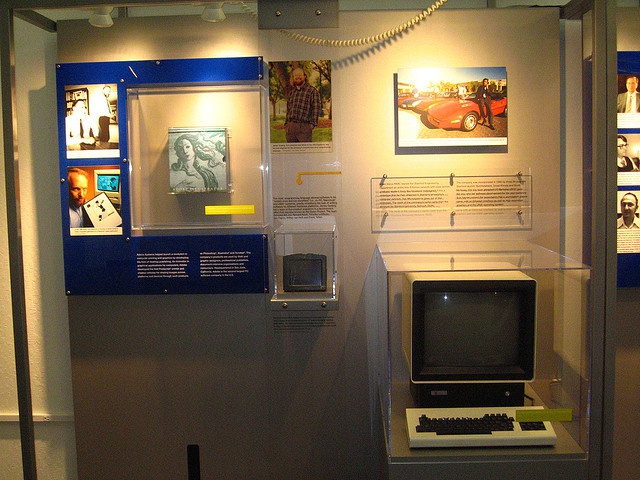Describe the objects in this image and their specific colors. I can see tv in black, maroon, and olive tones, keyboard in black, tan, gray, and olive tones, and tv in black and darkgreen tones in this image. 